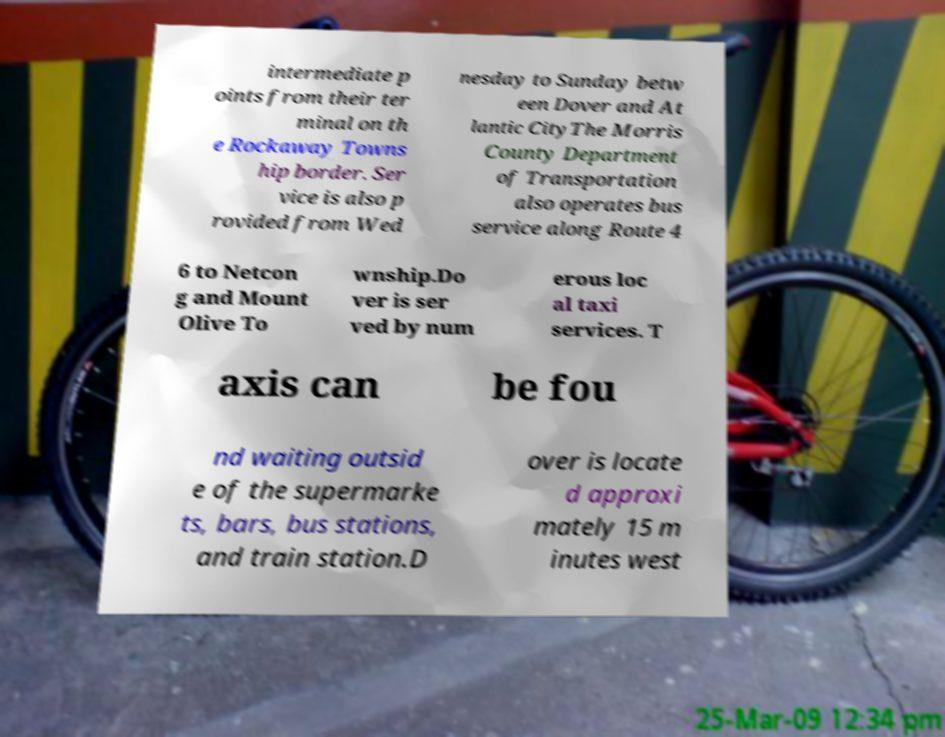Please read and relay the text visible in this image. What does it say? intermediate p oints from their ter minal on th e Rockaway Towns hip border. Ser vice is also p rovided from Wed nesday to Sunday betw een Dover and At lantic CityThe Morris County Department of Transportation also operates bus service along Route 4 6 to Netcon g and Mount Olive To wnship.Do ver is ser ved by num erous loc al taxi services. T axis can be fou nd waiting outsid e of the supermarke ts, bars, bus stations, and train station.D over is locate d approxi mately 15 m inutes west 